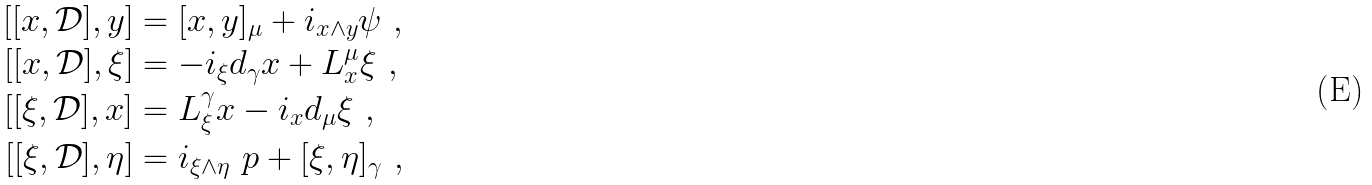<formula> <loc_0><loc_0><loc_500><loc_500>[ [ x , \mathcal { D } ] , y ] & = { [ x , y ] _ { \mu } } + { i _ { x \wedge y } \psi } \ , \\ [ [ x , \mathcal { D } ] , { \xi } ] & = - { i _ { \xi } d _ { \gamma } x } + { L ^ { \mu } _ { x } \xi } \ , \\ [ [ { \xi } , \mathcal { D } ] , x ] & = { L ^ { \gamma } _ { \xi } x } - { i _ { x } d _ { \mu } \xi } \ , \\ [ [ { \xi } , \mathcal { D } ] , { \eta } ] & = { i _ { \xi \wedge \eta } \ p } + { [ \xi , \eta ] _ { \gamma } } \ ,</formula> 